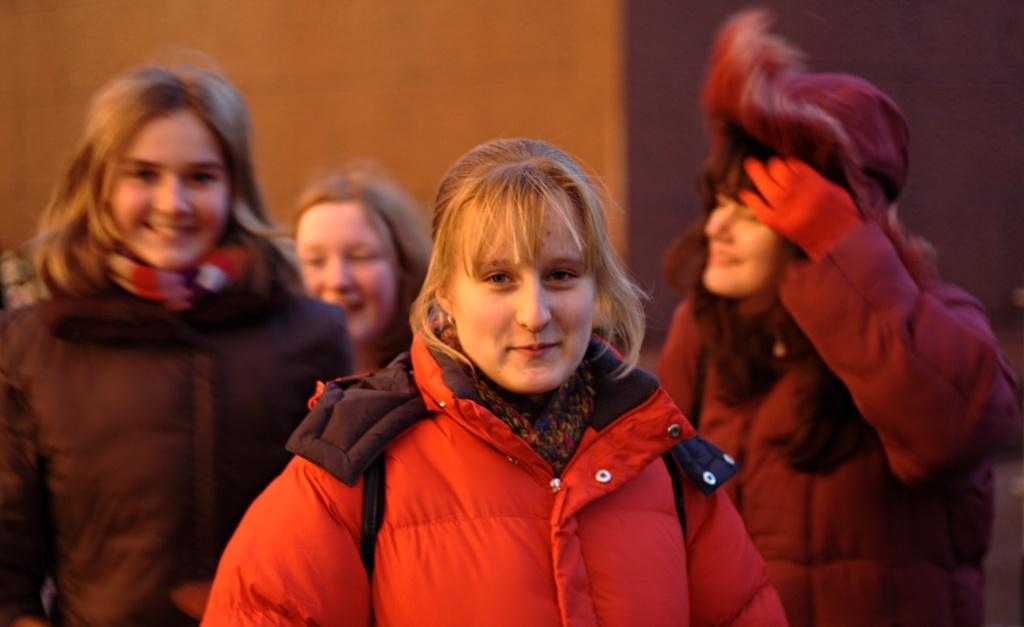What is the main subject of the image? The main subject of the image is a group of women. Where are the women located in the image? The women are standing in a place. What are the women wearing in the image? The women are wearing jackets. What is the facial expression of the women in the image? The women are smiling. What type of growth can be seen on the women's faces in the image? There is no growth visible on the women's faces in the image. How many trucks are parked near the women in the image? There are no trucks present in the image. 